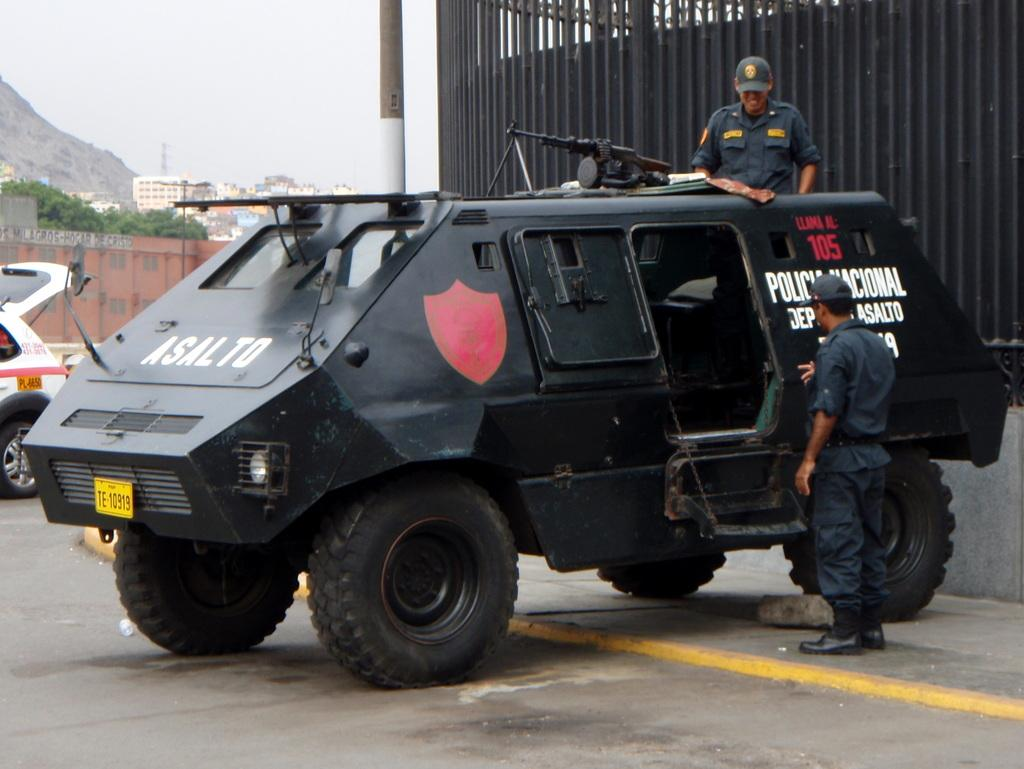How many vehicles are on the ground in the image? There are two vehicles on the ground in the image. Can you describe the people in the image? There are some persons in the image. What type of natural elements can be seen in the image? There are trees, mountains, and the sky visible in the image. What man-made structures are present in the image? There are buildings, a wall, and poles in the image. What additional object can be seen in the image? There is a grille in the image. What type of berry is being used as a prop in the image? There is no berry present in the image. How many feet are visible in the image? There is no reference to feet or any body parts in the image. 